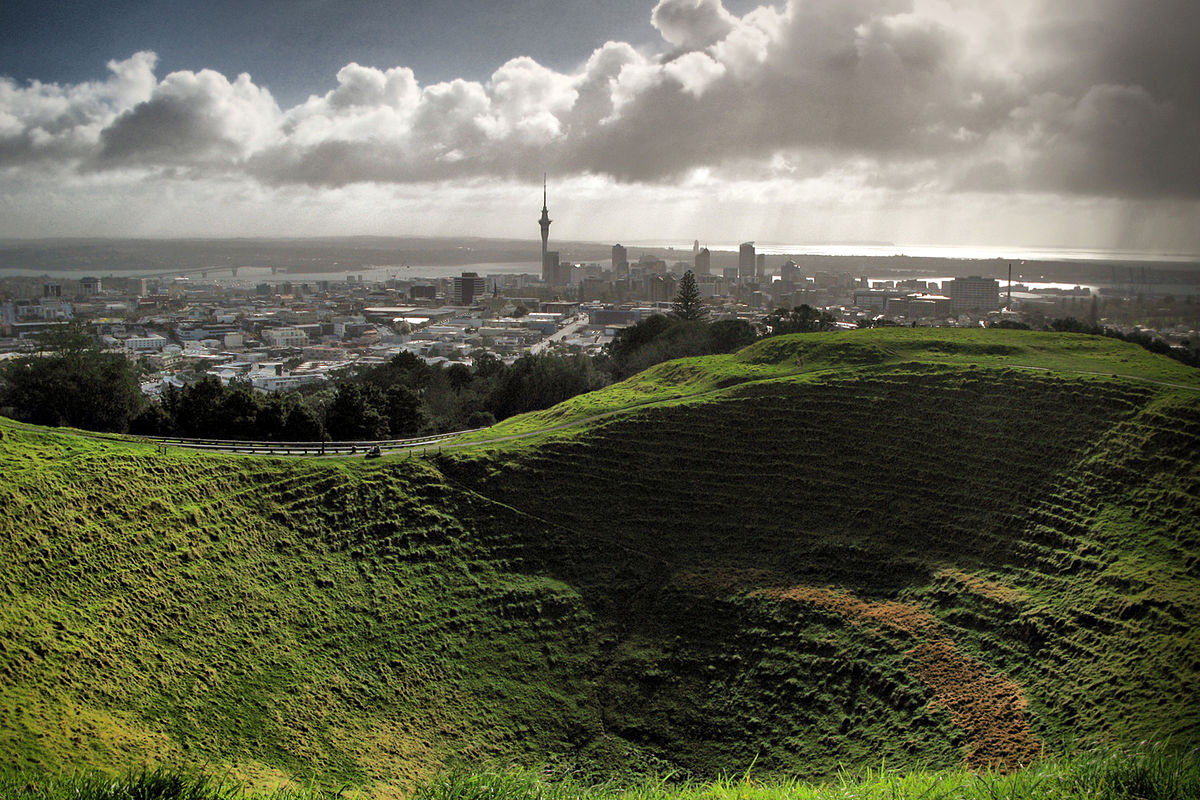Can you describe the main features of this image for me? The image presents a captivating scene from the Mt Eden Crater, a dormant volcano in Auckland, New Zealand. Looking out from the crater, one can see the expansive cityscape stretched below under a dramatic sky. The crater's slopes are covered in lush, vibrant green grass, marked by trails that suggest frequent visits by locals and tourists alike. The city in the distance is dotted with numerous buildings, including the iconic Sky Tower, piercing the skyline. Above, the sky is a play of light and shadow, with patches of blue peering through a cover of moody clouds, suggesting an early morning or late afternoon timing. The image beautifully juxtaposes the natural green spaces with the urban environment, providing a comprehensive overview of Auckland's geography and urban design. 